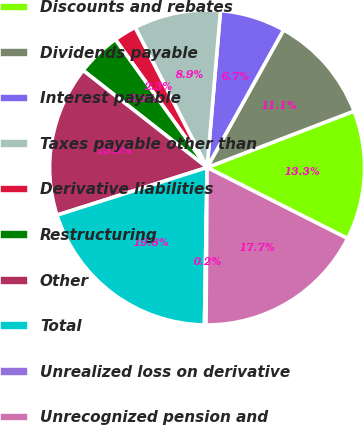<chart> <loc_0><loc_0><loc_500><loc_500><pie_chart><fcel>Discounts and rebates<fcel>Dividends payable<fcel>Interest payable<fcel>Taxes payable other than<fcel>Derivative liabilities<fcel>Restructuring<fcel>Other<fcel>Total<fcel>Unrealized loss on derivative<fcel>Unrecognized pension and<nl><fcel>13.28%<fcel>11.09%<fcel>6.72%<fcel>8.91%<fcel>2.34%<fcel>4.53%<fcel>15.47%<fcel>19.84%<fcel>0.16%<fcel>17.66%<nl></chart> 